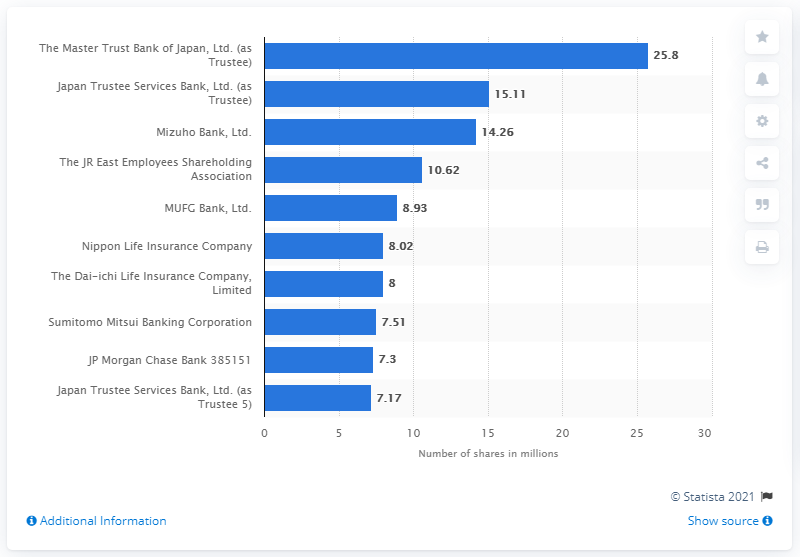Specify some key components in this picture. The Master Trust Bank of Japan, Ltd. owned 25.8 shares. 